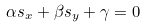Convert formula to latex. <formula><loc_0><loc_0><loc_500><loc_500>\alpha s _ { x } + \beta s _ { y } + \gamma = 0</formula> 